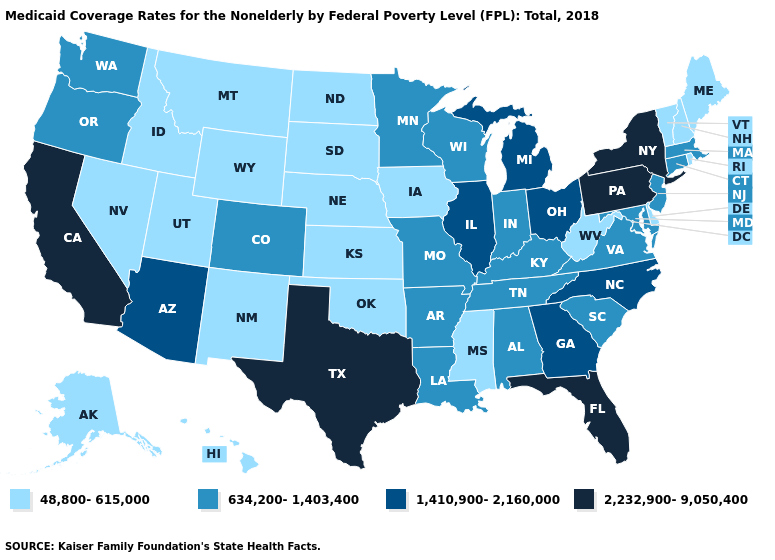Name the states that have a value in the range 634,200-1,403,400?
Be succinct. Alabama, Arkansas, Colorado, Connecticut, Indiana, Kentucky, Louisiana, Maryland, Massachusetts, Minnesota, Missouri, New Jersey, Oregon, South Carolina, Tennessee, Virginia, Washington, Wisconsin. Among the states that border South Dakota , which have the highest value?
Short answer required. Minnesota. Does Louisiana have a lower value than Texas?
Write a very short answer. Yes. Does Tennessee have the highest value in the South?
Keep it brief. No. Does Texas have the highest value in the South?
Quick response, please. Yes. What is the value of Pennsylvania?
Concise answer only. 2,232,900-9,050,400. What is the highest value in the West ?
Write a very short answer. 2,232,900-9,050,400. What is the value of Ohio?
Be succinct. 1,410,900-2,160,000. Does New Mexico have a lower value than North Carolina?
Give a very brief answer. Yes. What is the value of North Carolina?
Answer briefly. 1,410,900-2,160,000. Is the legend a continuous bar?
Give a very brief answer. No. Among the states that border California , which have the lowest value?
Keep it brief. Nevada. What is the highest value in states that border Pennsylvania?
Answer briefly. 2,232,900-9,050,400. Does California have the lowest value in the USA?
Concise answer only. No. What is the highest value in the Northeast ?
Concise answer only. 2,232,900-9,050,400. 